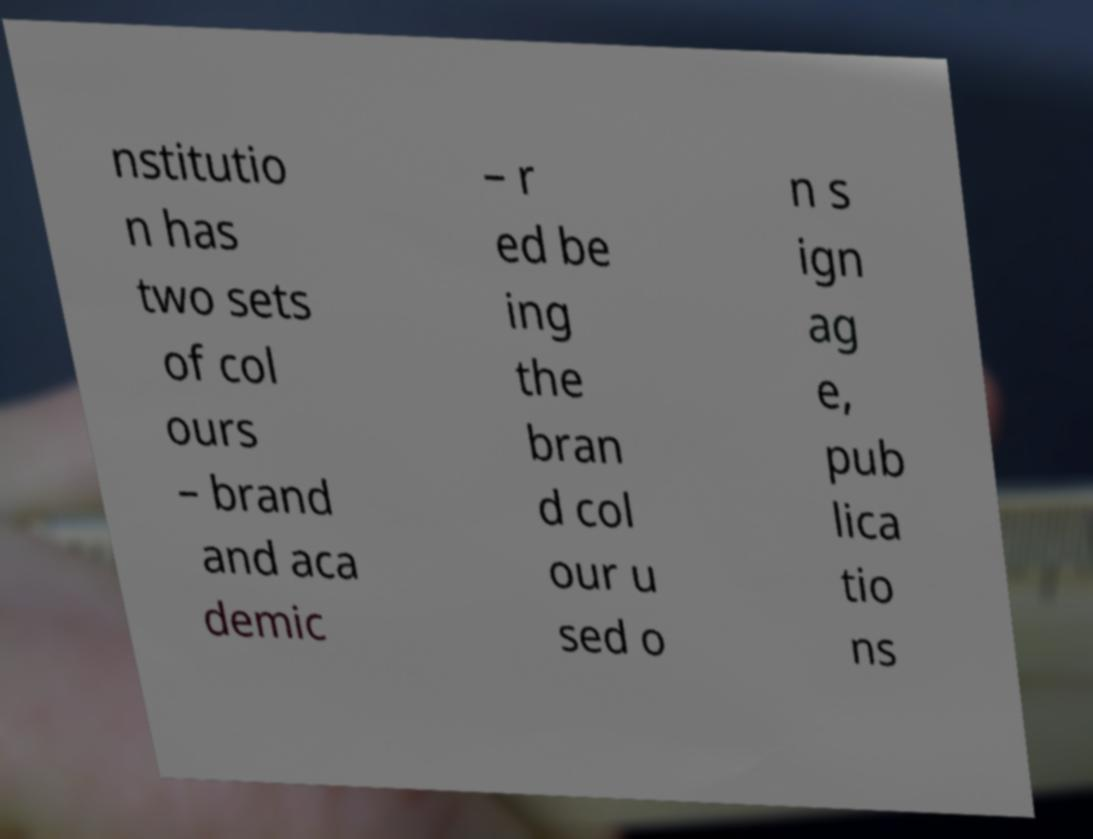What messages or text are displayed in this image? I need them in a readable, typed format. nstitutio n has two sets of col ours – brand and aca demic – r ed be ing the bran d col our u sed o n s ign ag e, pub lica tio ns 